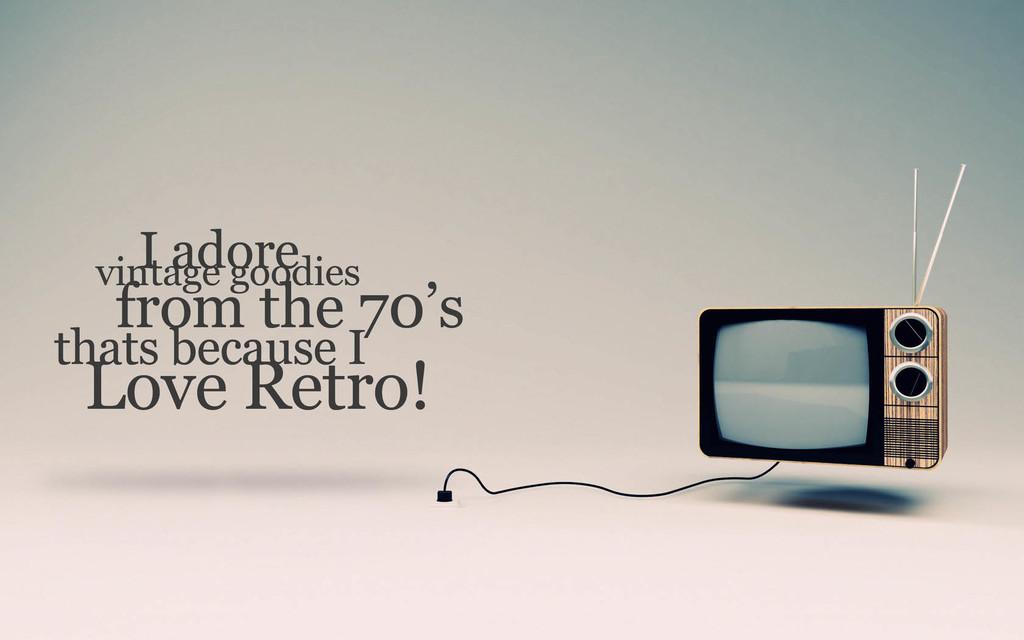What brand of television is that?
Ensure brevity in your answer.  Unanswerable. 